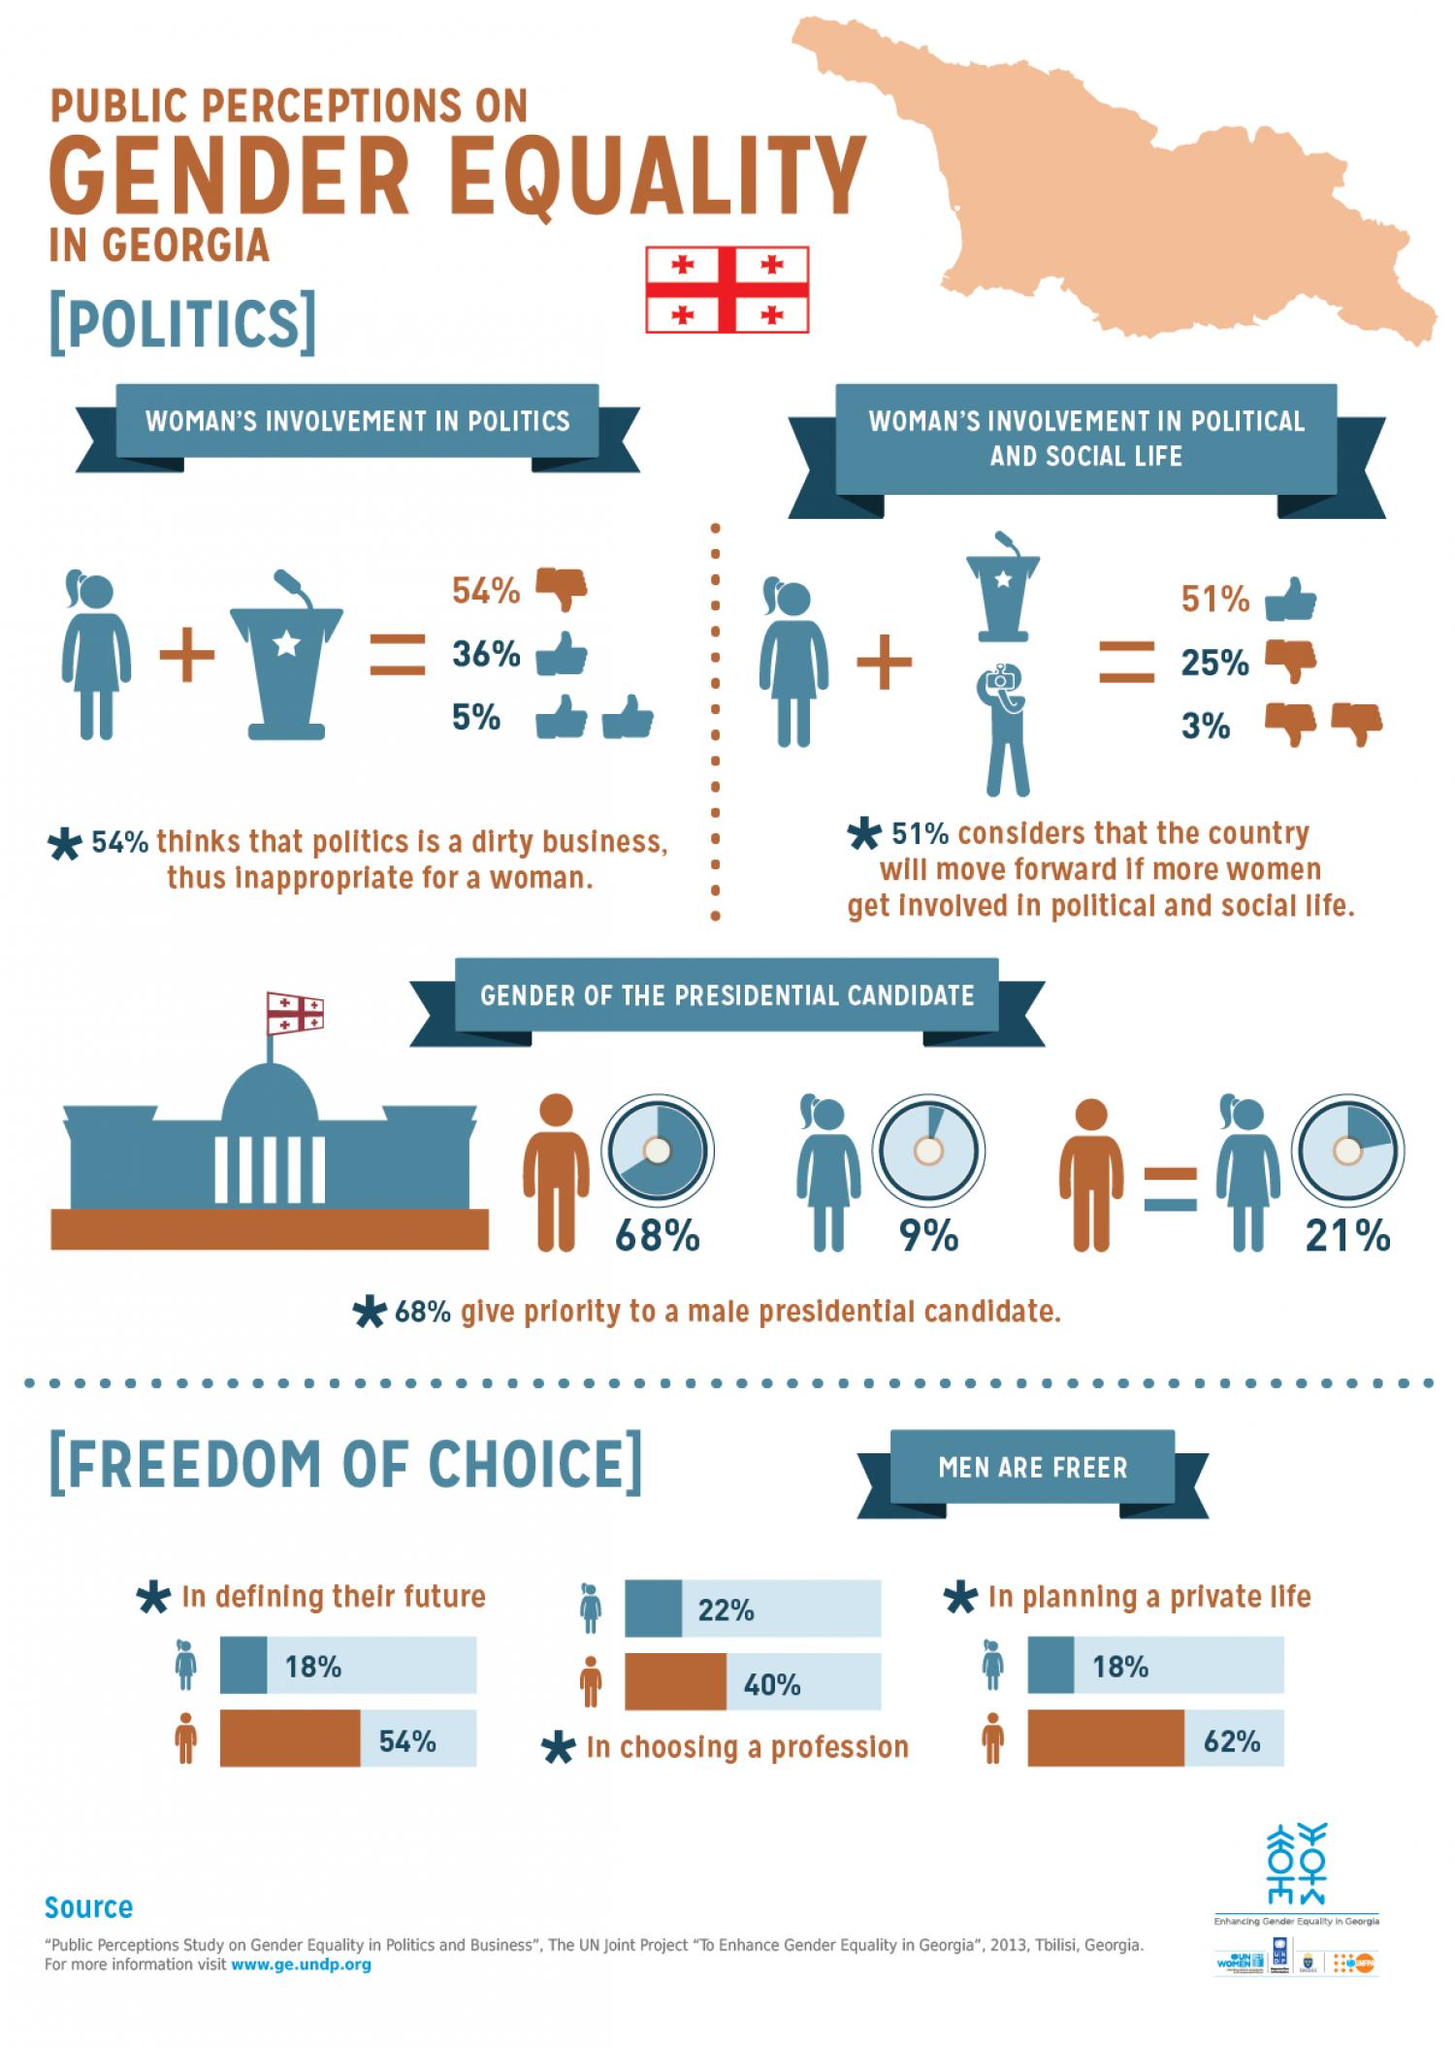Draw attention to some important aspects in this diagram. According to the survey, 21% of Georgians give equal priority to both male and female presidential candidates. According to a survey in Georgia, 22% of women reported feeling free to choose their profession. According to a recent survey, only 9% of Georgians prioritize a female presidential candidate. According to the survey conducted in Georgia, only 18% of women felt free to define their future. In Georgia, 62% of men are able to plan their private life freely. 